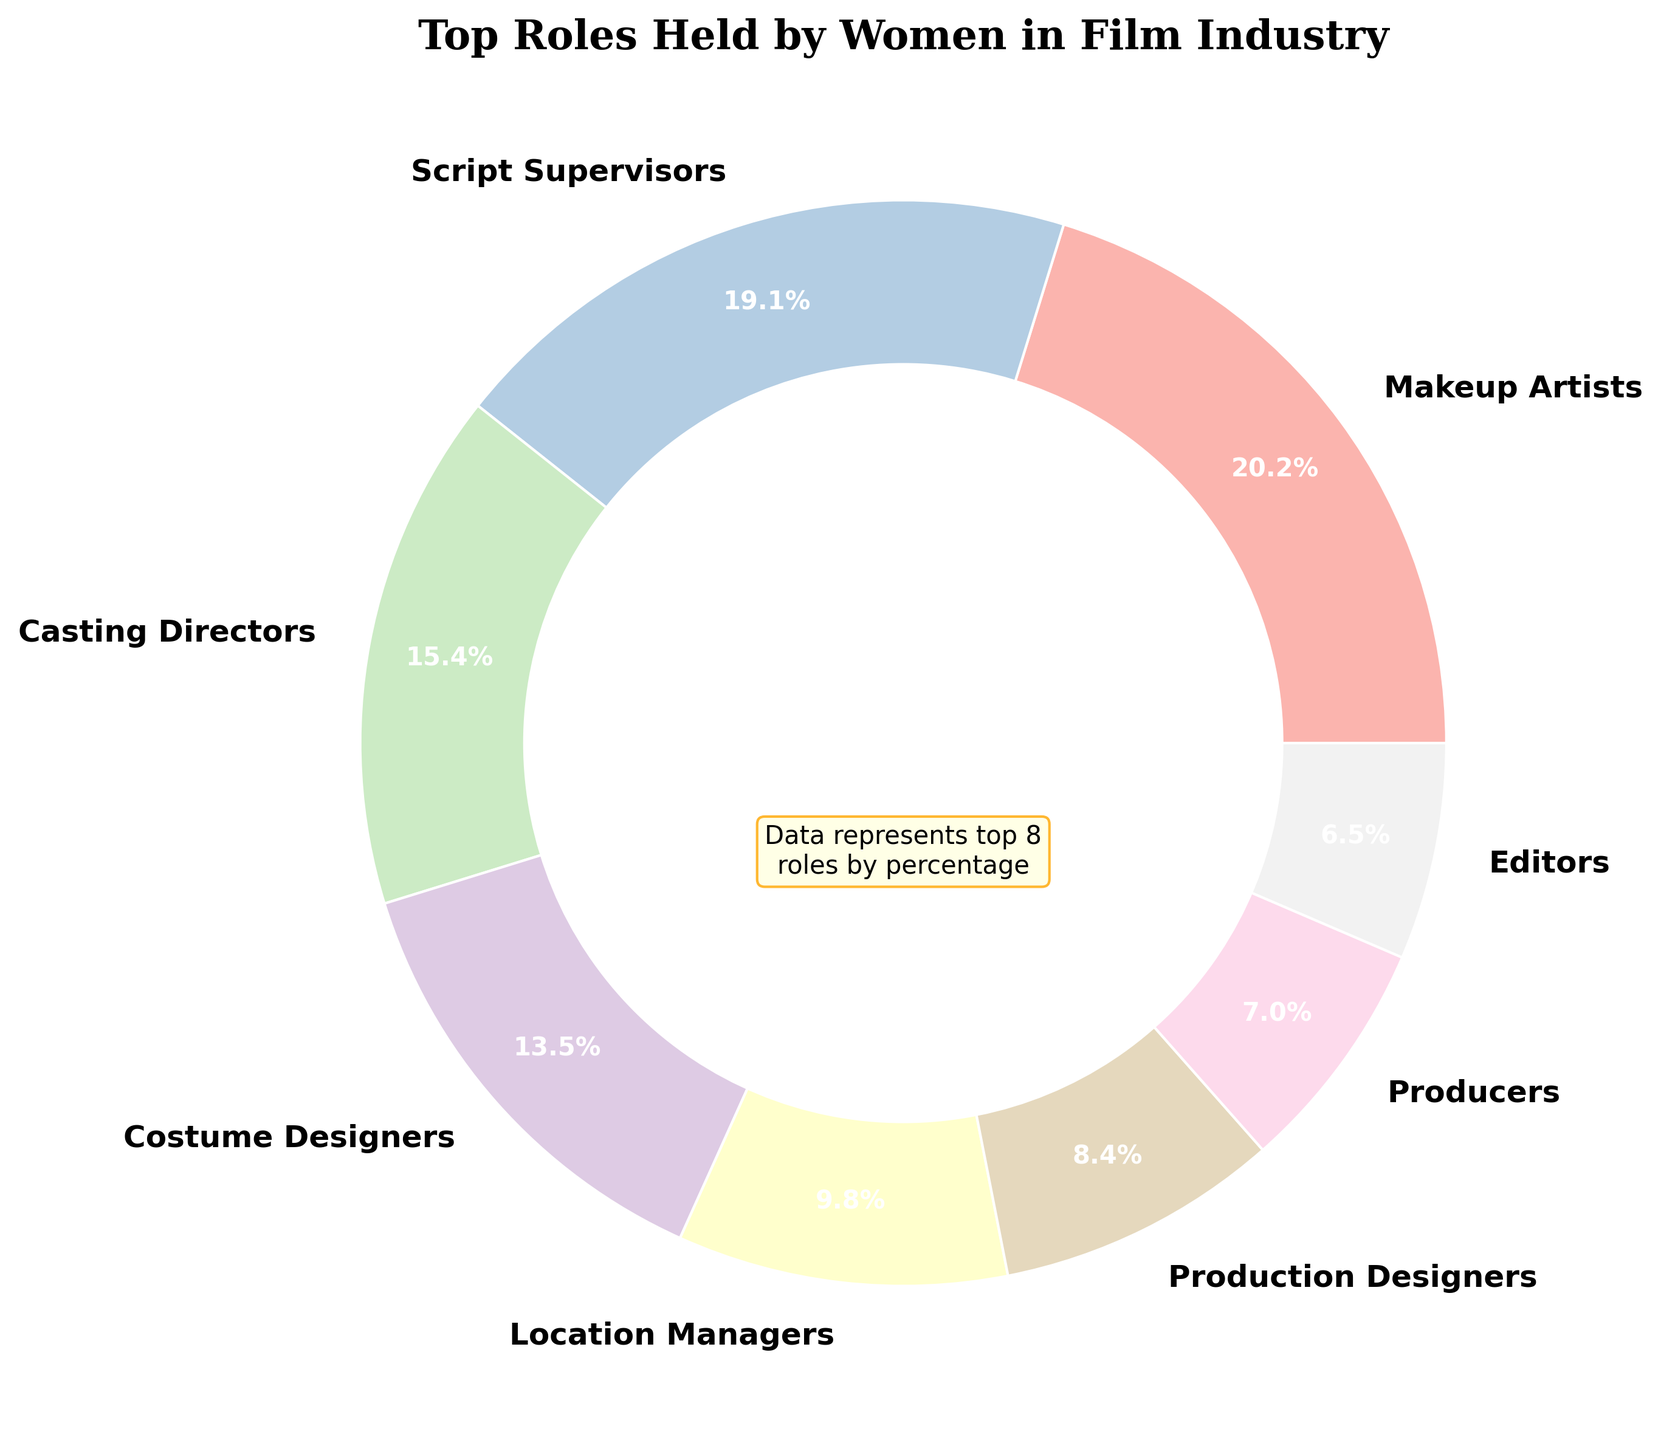What's the percentage of script supervisors compared to directors? The percentage of script supervisors is 68% while directors are at 12%. To compare, subtract 12 from 68, resulting in a difference of 56%. So script supervisors have a 56% higher representation.
Answer: 56% Which role has the highest percentage and what is it? By looking at the pie chart, makeup artists have the highest percentage at 72%.
Answer: 72% How do the percentages of producers and editors compare? The pie chart shows that producers are at 25% and editors at 23%. Therefore, producers have a 2% higher representation than editors.
Answer: Producers: 25%, Editors: 23% What is the combined percentage of roles held by costume designers and casting directors? The percentage for costume designers is 48% and for casting directors, it's 55%. Adding these together, 48% + 55% = 103%.
Answer: 103% Which role is represented by the green segment and what is its percentage? The pie chart uses color distinctions for segments. Upon inspection, the green segment corresponds to location managers at 35%.
Answer: Location Managers: 35% Are there more cinematographers or music composers? The percentage of cinematographers is 6%, while music composers are at 7%. Thus, there are slightly more music composers than cinematographers.
Answer: Music Composers: 7%, Cinematographers: 6% What's the combined percentage of the top three roles? The top three roles by percentage are makeup artists (72%), script supervisors (68%), and casting directors (55%). Adding these together: 72% + 68% + 55% = 195%.
Answer: 195% Which role falls into the lowest three percentages, and what are their values? Reviewing the chart, the lowest three percentages are music composers (7%), cinematographers (6%), and directors (12%).
Answer: Music Composers: 7%, Cinematographers: 6%, Directors: 12% What is the average percentage of the shown roles in the chart? The top 8 roles' percentages are 72%, 68%, 55%, 48%, 35%, 25%, 23%, and 20%. Summing these yields 346%. Dividing by 8 results in an average of 43.25%.
Answer: 43.25% 